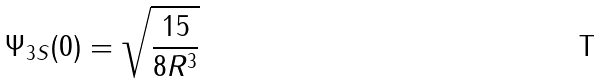<formula> <loc_0><loc_0><loc_500><loc_500>\Psi _ { 3 S } ( 0 ) = \sqrt { \frac { 1 5 } { 8 R ^ { 3 } } }</formula> 